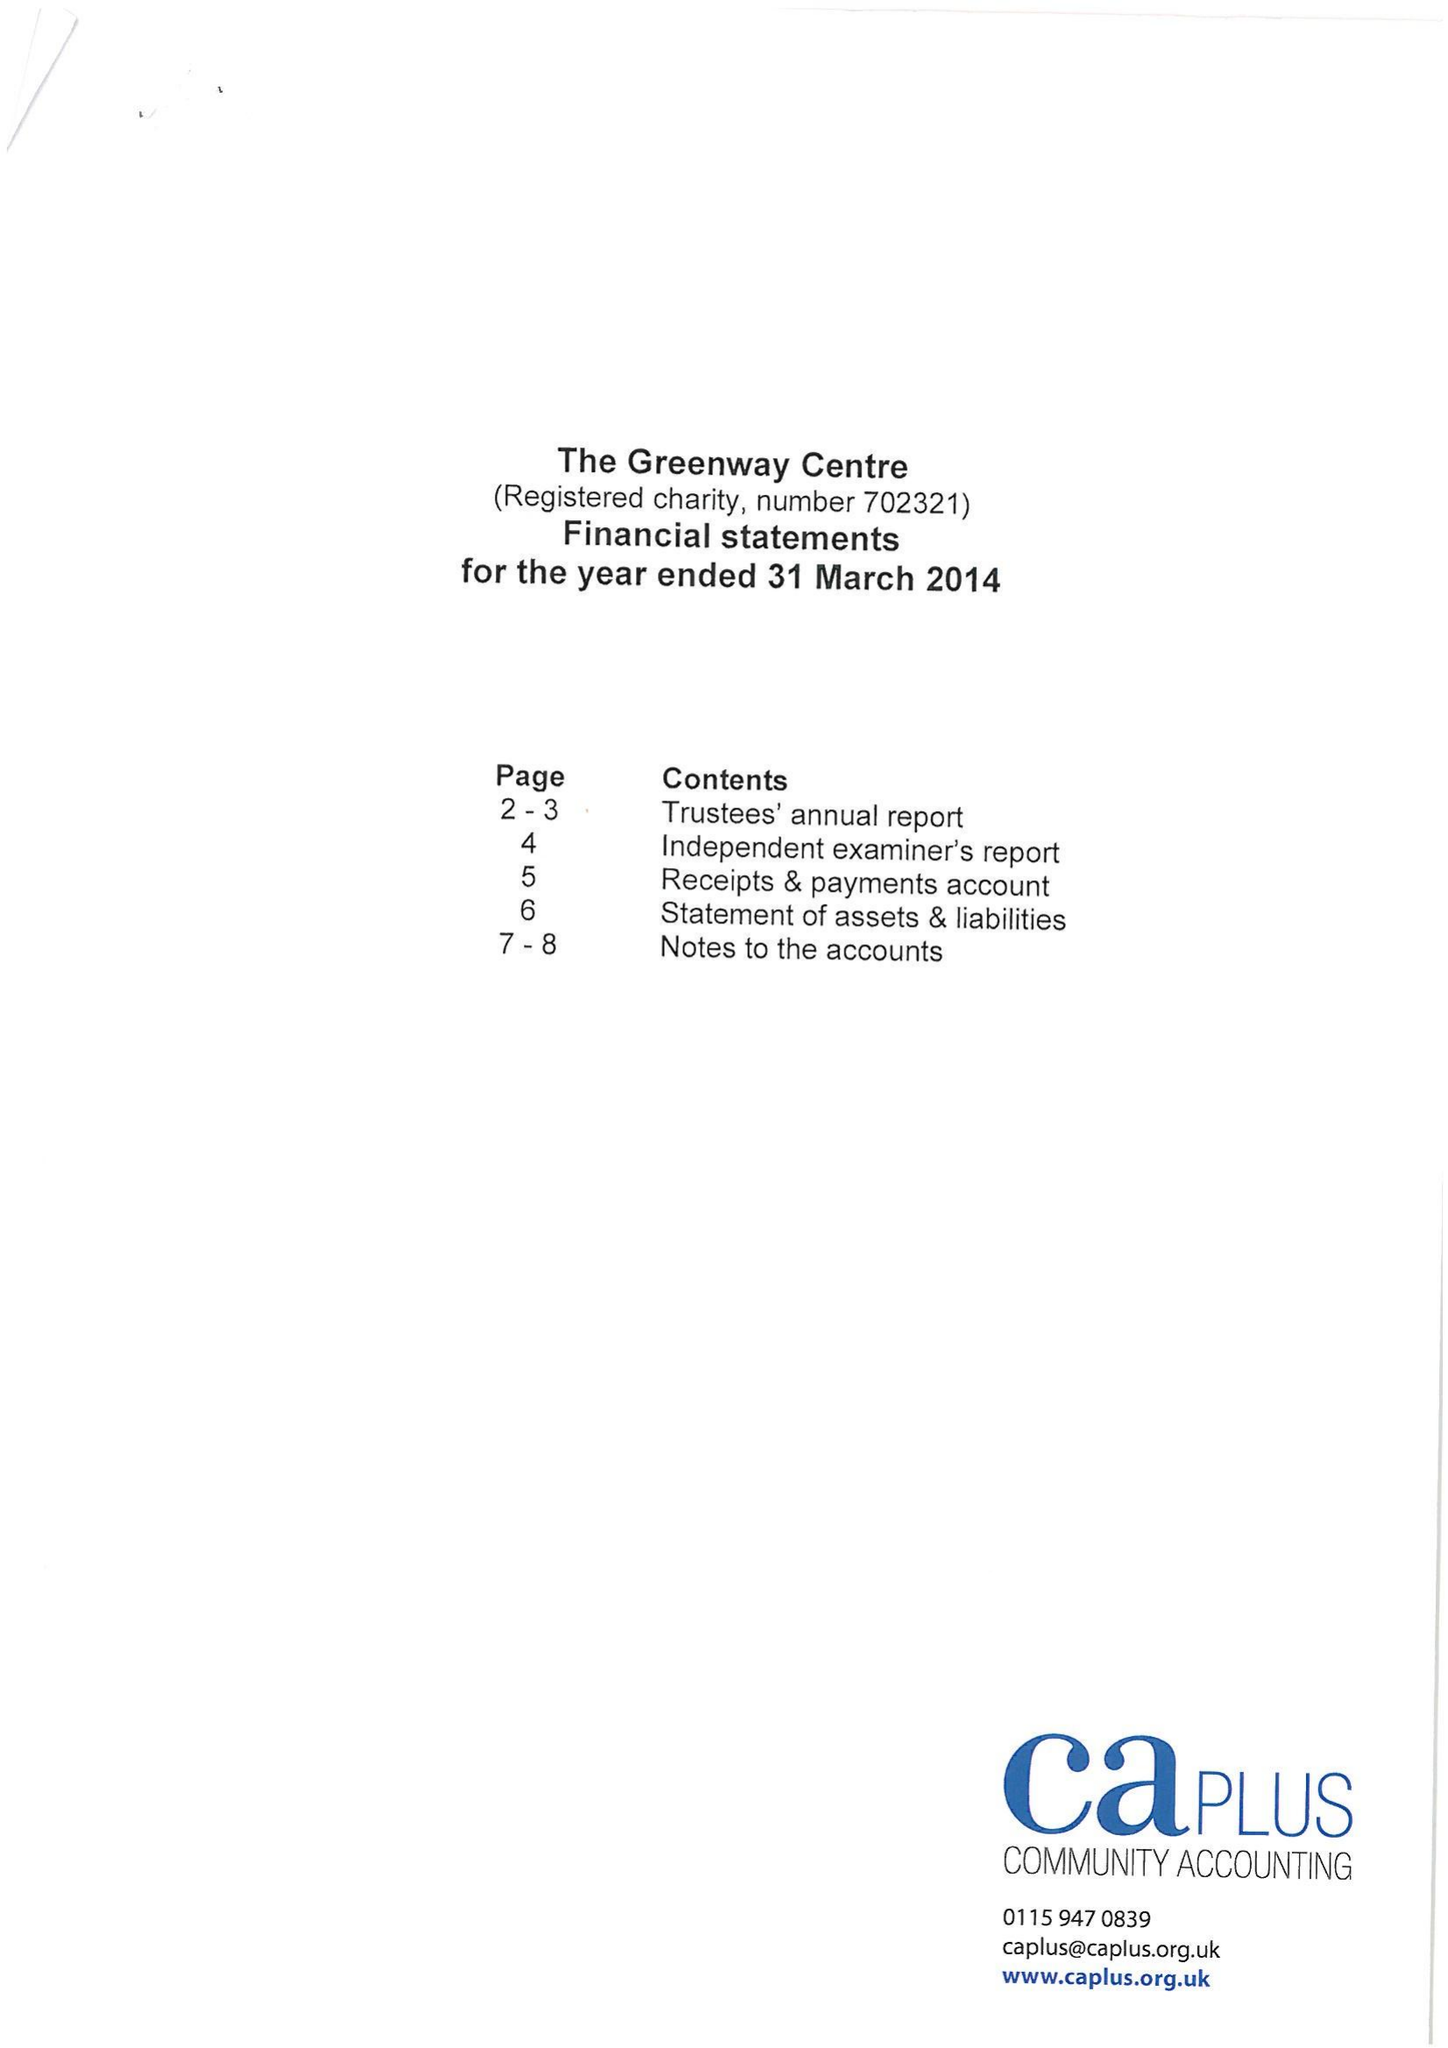What is the value for the income_annually_in_british_pounds?
Answer the question using a single word or phrase. 107471.00 